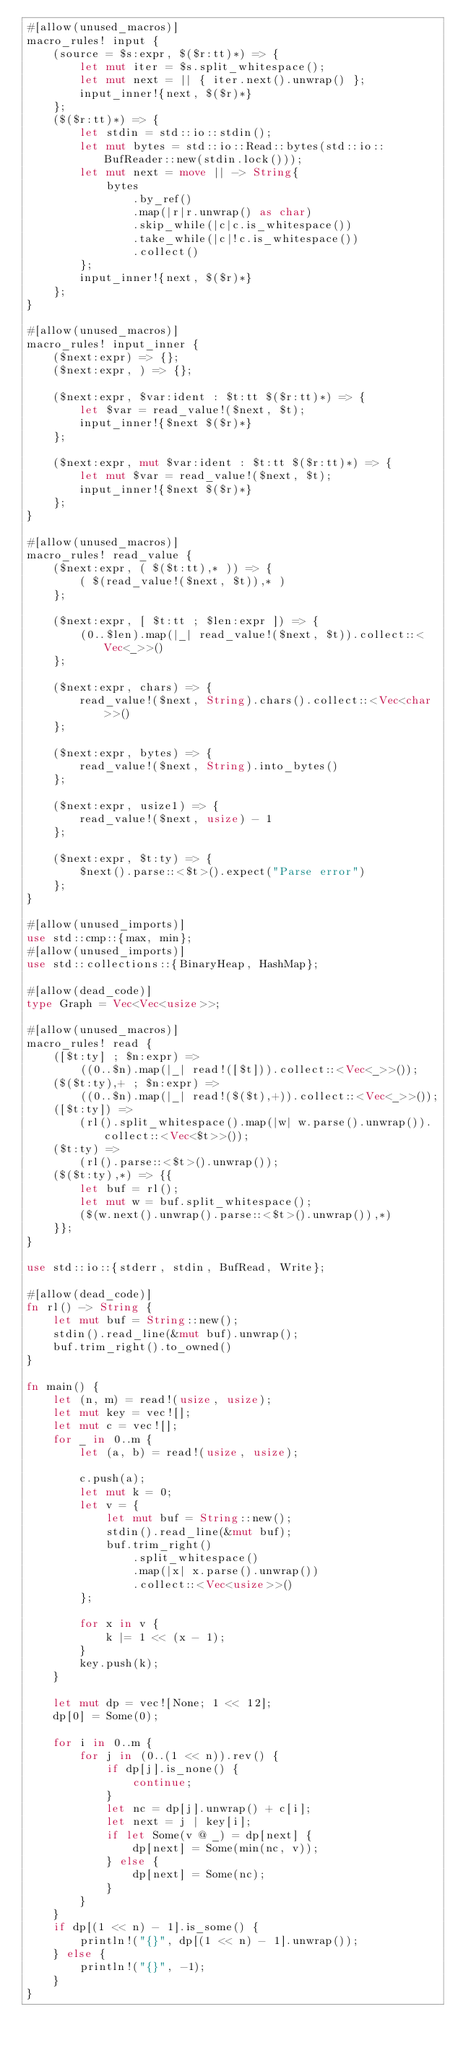Convert code to text. <code><loc_0><loc_0><loc_500><loc_500><_Rust_>#[allow(unused_macros)]
macro_rules! input {
    (source = $s:expr, $($r:tt)*) => {
        let mut iter = $s.split_whitespace();
        let mut next = || { iter.next().unwrap() };
        input_inner!{next, $($r)*}
    };
    ($($r:tt)*) => {
        let stdin = std::io::stdin();
        let mut bytes = std::io::Read::bytes(std::io::BufReader::new(stdin.lock()));
        let mut next = move || -> String{
            bytes
                .by_ref()
                .map(|r|r.unwrap() as char)
                .skip_while(|c|c.is_whitespace())
                .take_while(|c|!c.is_whitespace())
                .collect()
        };
        input_inner!{next, $($r)*}
    };
}

#[allow(unused_macros)]
macro_rules! input_inner {
    ($next:expr) => {};
    ($next:expr, ) => {};

    ($next:expr, $var:ident : $t:tt $($r:tt)*) => {
        let $var = read_value!($next, $t);
        input_inner!{$next $($r)*}
    };

    ($next:expr, mut $var:ident : $t:tt $($r:tt)*) => {
        let mut $var = read_value!($next, $t);
        input_inner!{$next $($r)*}
    };
}

#[allow(unused_macros)]
macro_rules! read_value {
    ($next:expr, ( $($t:tt),* )) => {
        ( $(read_value!($next, $t)),* )
    };

    ($next:expr, [ $t:tt ; $len:expr ]) => {
        (0..$len).map(|_| read_value!($next, $t)).collect::<Vec<_>>()
    };

    ($next:expr, chars) => {
        read_value!($next, String).chars().collect::<Vec<char>>()
    };

    ($next:expr, bytes) => {
        read_value!($next, String).into_bytes()
    };

    ($next:expr, usize1) => {
        read_value!($next, usize) - 1
    };

    ($next:expr, $t:ty) => {
        $next().parse::<$t>().expect("Parse error")
    };
}

#[allow(unused_imports)]
use std::cmp::{max, min};
#[allow(unused_imports)]
use std::collections::{BinaryHeap, HashMap};

#[allow(dead_code)]
type Graph = Vec<Vec<usize>>;

#[allow(unused_macros)]
macro_rules! read {
    ([$t:ty] ; $n:expr) =>
        ((0..$n).map(|_| read!([$t])).collect::<Vec<_>>());
    ($($t:ty),+ ; $n:expr) =>
        ((0..$n).map(|_| read!($($t),+)).collect::<Vec<_>>());
    ([$t:ty]) =>
        (rl().split_whitespace().map(|w| w.parse().unwrap()).collect::<Vec<$t>>());
    ($t:ty) =>
        (rl().parse::<$t>().unwrap());
    ($($t:ty),*) => {{
        let buf = rl();
        let mut w = buf.split_whitespace();
        ($(w.next().unwrap().parse::<$t>().unwrap()),*)
    }};
}

use std::io::{stderr, stdin, BufRead, Write};

#[allow(dead_code)]
fn rl() -> String {
    let mut buf = String::new();
    stdin().read_line(&mut buf).unwrap();
    buf.trim_right().to_owned()
}

fn main() {
    let (n, m) = read!(usize, usize);
    let mut key = vec![];
    let mut c = vec![];
    for _ in 0..m {
        let (a, b) = read!(usize, usize);

        c.push(a);
        let mut k = 0;
        let v = {
            let mut buf = String::new();
            stdin().read_line(&mut buf);
            buf.trim_right()
                .split_whitespace()
                .map(|x| x.parse().unwrap())
                .collect::<Vec<usize>>()
        };

        for x in v {
            k |= 1 << (x - 1);
        }
        key.push(k);
    }

    let mut dp = vec![None; 1 << 12];
    dp[0] = Some(0);

    for i in 0..m {
        for j in (0..(1 << n)).rev() {
            if dp[j].is_none() {
                continue;
            }
            let nc = dp[j].unwrap() + c[i];
            let next = j | key[i];
            if let Some(v @ _) = dp[next] {
                dp[next] = Some(min(nc, v));
            } else {
                dp[next] = Some(nc);
            }
        }
    }
    if dp[(1 << n) - 1].is_some() {
        println!("{}", dp[(1 << n) - 1].unwrap());
    } else {
        println!("{}", -1);
    }
}
</code> 